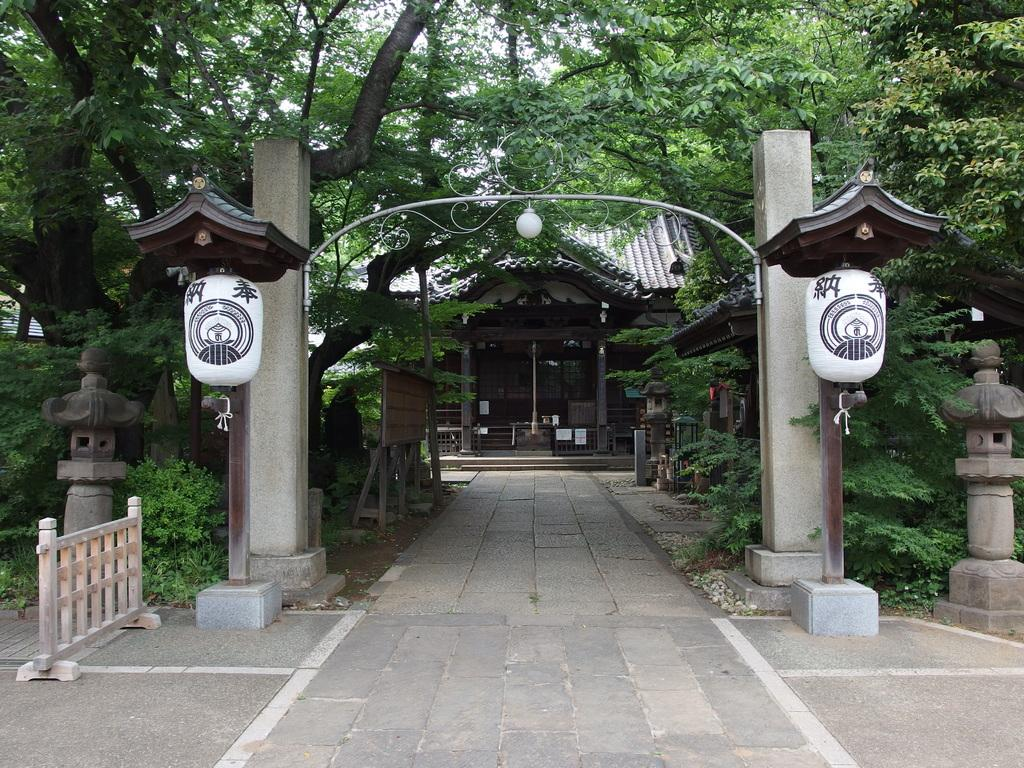How many pillars can be seen in the image? There are two pillars in the image. What type of structure is present in the image? There is a fence in the image. What type of vegetation is visible in the image? There are plants and trees in the image. What type of building is in the image? There is a house in the image. What type of path is present in the image? There is a footpath in the image. Can you tell me the name of the person who made the request at the airport in the image? There is no airport or request present in the image; it features two pillars, a fence, plants, trees, a house, and a footpath. 